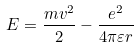Convert formula to latex. <formula><loc_0><loc_0><loc_500><loc_500>E = \frac { m v ^ { 2 } } { 2 } - \frac { e ^ { 2 } } { 4 \pi \varepsilon r }</formula> 